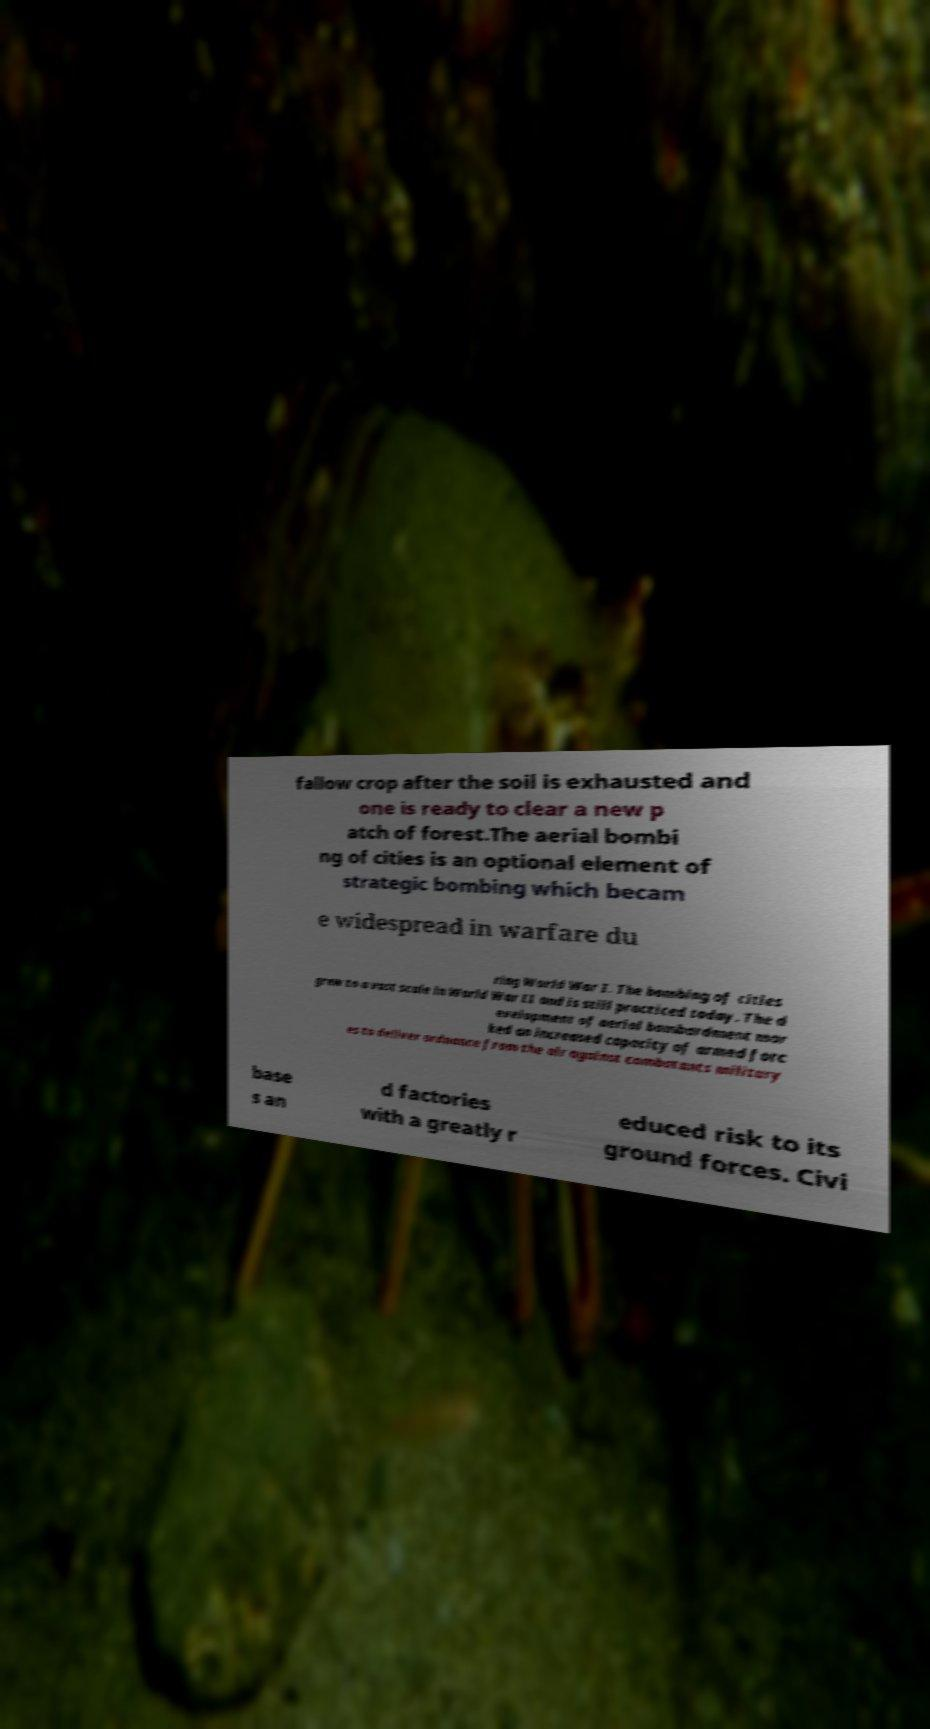For documentation purposes, I need the text within this image transcribed. Could you provide that? fallow crop after the soil is exhausted and one is ready to clear a new p atch of forest.The aerial bombi ng of cities is an optional element of strategic bombing which becam e widespread in warfare du ring World War I. The bombing of cities grew to a vast scale in World War II and is still practiced today. The d evelopment of aerial bombardment mar ked an increased capacity of armed forc es to deliver ordnance from the air against combatants military base s an d factories with a greatly r educed risk to its ground forces. Civi 